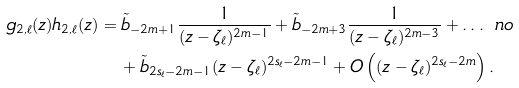<formula> <loc_0><loc_0><loc_500><loc_500>g _ { 2 , \ell } ( z ) h _ { 2 , \ell } ( z ) & = \tilde { b } _ { - 2 m + 1 } \frac { 1 } { ( z - \zeta _ { \ell } ) ^ { 2 m - 1 } } + \tilde { b } _ { - 2 m + 3 } \frac { 1 } { ( z - \zeta _ { \ell } ) ^ { 2 m - 3 } } + \dots \ n o \\ & \quad + \tilde { b } _ { 2 s _ { \ell } - 2 m - 1 } ( z - \zeta _ { \ell } ) ^ { 2 s _ { \ell } - 2 m - 1 } + O \left ( ( z - \zeta _ { \ell } ) ^ { 2 s _ { \ell } - 2 m } \right ) .</formula> 